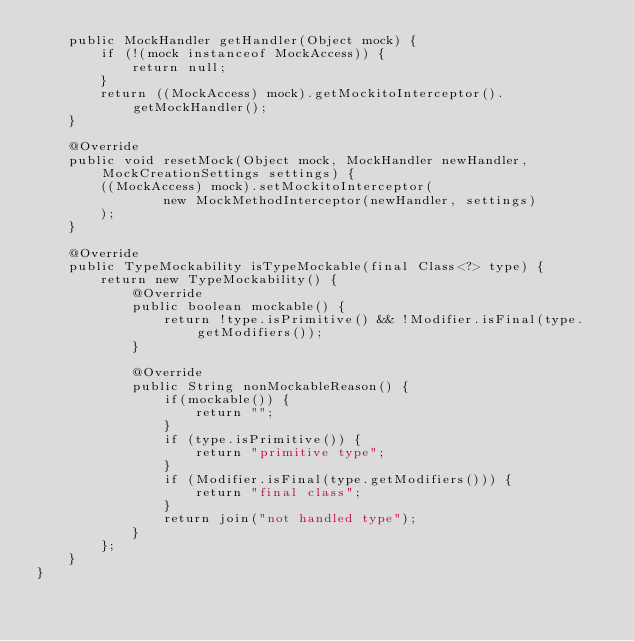<code> <loc_0><loc_0><loc_500><loc_500><_Java_>    public MockHandler getHandler(Object mock) {
        if (!(mock instanceof MockAccess)) {
            return null;
        }
        return ((MockAccess) mock).getMockitoInterceptor().getMockHandler();
    }

    @Override
    public void resetMock(Object mock, MockHandler newHandler, MockCreationSettings settings) {
        ((MockAccess) mock).setMockitoInterceptor(
                new MockMethodInterceptor(newHandler, settings)
        );
    }

    @Override
    public TypeMockability isTypeMockable(final Class<?> type) {
        return new TypeMockability() {
            @Override
            public boolean mockable() {
                return !type.isPrimitive() && !Modifier.isFinal(type.getModifiers());
            }

            @Override
            public String nonMockableReason() {
                if(mockable()) {
                    return "";
                }
                if (type.isPrimitive()) {
                    return "primitive type";
                }
                if (Modifier.isFinal(type.getModifiers())) {
                    return "final class";
                }
                return join("not handled type");
            }
        };
    }
}
</code> 